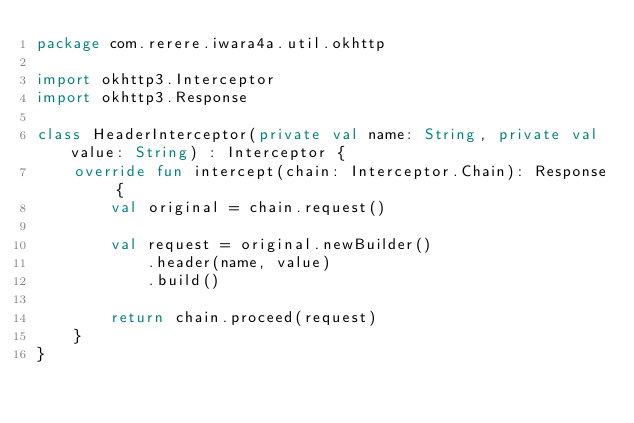Convert code to text. <code><loc_0><loc_0><loc_500><loc_500><_Kotlin_>package com.rerere.iwara4a.util.okhttp

import okhttp3.Interceptor
import okhttp3.Response

class HeaderInterceptor(private val name: String, private val value: String) : Interceptor {
    override fun intercept(chain: Interceptor.Chain): Response {
        val original = chain.request()

        val request = original.newBuilder()
            .header(name, value)
            .build()

        return chain.proceed(request)
    }
}</code> 